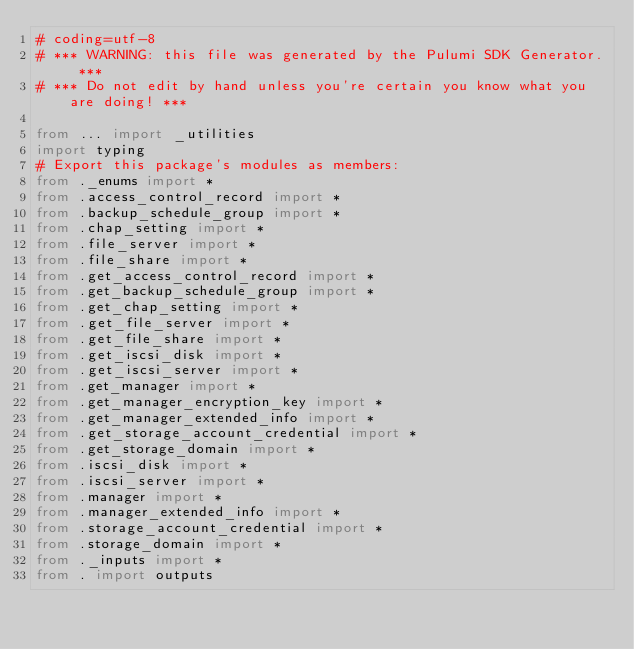<code> <loc_0><loc_0><loc_500><loc_500><_Python_># coding=utf-8
# *** WARNING: this file was generated by the Pulumi SDK Generator. ***
# *** Do not edit by hand unless you're certain you know what you are doing! ***

from ... import _utilities
import typing
# Export this package's modules as members:
from ._enums import *
from .access_control_record import *
from .backup_schedule_group import *
from .chap_setting import *
from .file_server import *
from .file_share import *
from .get_access_control_record import *
from .get_backup_schedule_group import *
from .get_chap_setting import *
from .get_file_server import *
from .get_file_share import *
from .get_iscsi_disk import *
from .get_iscsi_server import *
from .get_manager import *
from .get_manager_encryption_key import *
from .get_manager_extended_info import *
from .get_storage_account_credential import *
from .get_storage_domain import *
from .iscsi_disk import *
from .iscsi_server import *
from .manager import *
from .manager_extended_info import *
from .storage_account_credential import *
from .storage_domain import *
from ._inputs import *
from . import outputs
</code> 